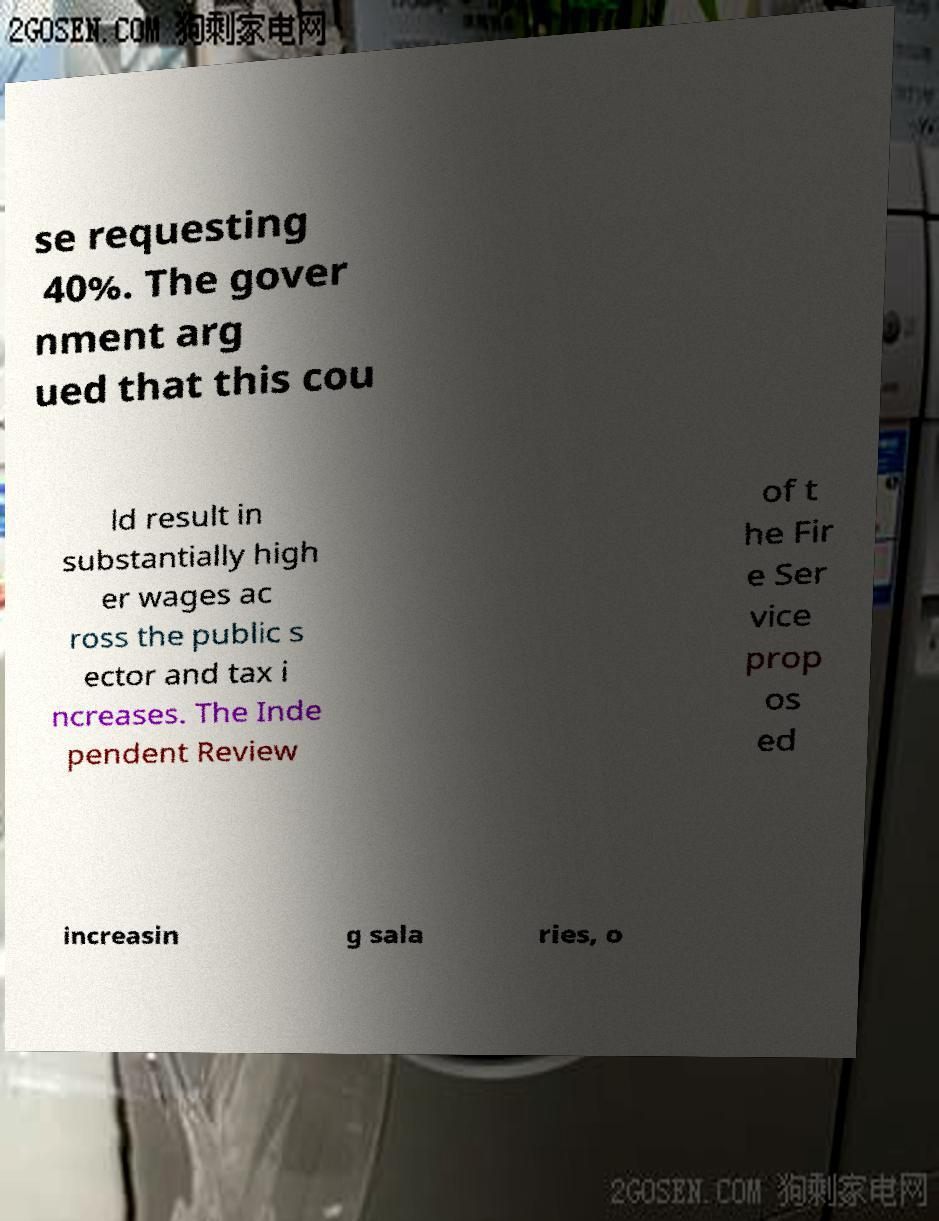Can you accurately transcribe the text from the provided image for me? se requesting 40%. The gover nment arg ued that this cou ld result in substantially high er wages ac ross the public s ector and tax i ncreases. The Inde pendent Review of t he Fir e Ser vice prop os ed increasin g sala ries, o 